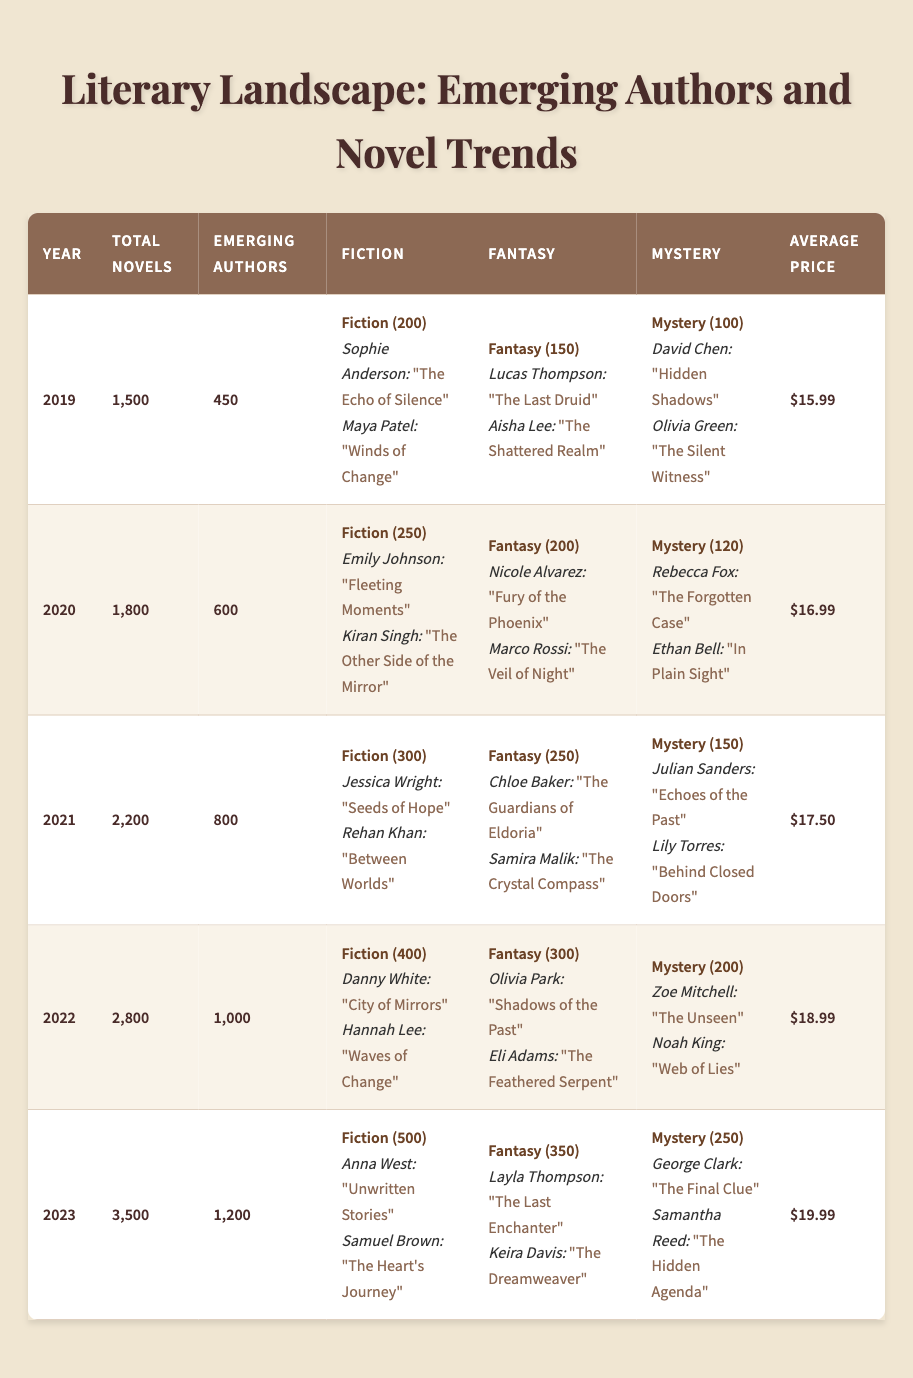What was the total number of novels published by emerging authors in 2022? The table lists that in 2022, there were 2,800 total novels published, and out of those, 1,000 were by emerging authors. Therefore, the answer is directly found in the table.
Answer: 1,000 Which genre had the highest number of novels published by emerging authors in 2021? In 2021, the fiction genre had 300 novels, fantasy had 250 novels, and mystery had 150 novels. Since 300 is the highest, the answer is fiction.
Answer: Fiction What was the increase in the number of emerging authors from 2019 to 2023? There were 450 emerging authors in 2019 and 1,200 in 2023. The increase is calculated by subtracting the two values: 1,200 - 450 = 750.
Answer: 750 Was the average price of novels higher in 2023 than in 2020? In 2023, the average price was $19.99, while in 2020 it was $16.99. Since $19.99 is greater than $16.99, this statement is true.
Answer: Yes How many total novels were published in the years 2019, 2020, and 2021 combined? The total novels for 2019 is 1,500, for 2020 is 1,800, and for 2021 is 2,200. Combining these values: 1,500 + 1,800 + 2,200 = 5,500 novels.
Answer: 5,500 Which year saw the most significant increase in the number of emerging authors? Comparing the data, from 2021 (800 authors) to 2022 (1,000 authors) is an increase of 200, and from 2022 (1,000 authors) to 2023 (1,200 authors) is an increase of 200. However, the increase from 2020 (600 authors) to 2021 (800 authors) is 200 as well. The increase between 2019 (450) and 2020 (600) is 150. Thus, each of the latter years had the highest increase of 200.
Answer: 2021-2022 and 2022-2023 What were the average prices of novels in the years with the highest publication rates? The years with the highest publication rates are 2022 (average price $18.99) and 2023 (average price $19.99). Thus, the average prices are compared, and $19.99 is the highest in 2023.
Answer: $19.99 In what year did fantasy novels by emerging authors reach 300 published works? In the table, fantasy novels reached 300 published works in 2022, as the previous years indicated lower numbers.
Answer: 2022 What percentage of the total novels published in 2023 were authored by emerging writers? In 2023, there were 3,500 total novels and 1,200 were authored by emerging authors. The percentage is calculated as (1,200 / 3,500) * 100, which equals approximately 34.29%.
Answer: 34.29% How many more novels in the mystery genre were published in 2023 compared to 2019? In 2023, 250 mystery novels were published, compared to 100 in 2019. Therefore, the difference is calculated as 250 - 100 = 150 more novels.
Answer: 150 Was there a consistent increase in total novels published each year from 2019 to 2023? By examining the total novels published in each year: 1,500 (2019), 1,800 (2020), 2,200 (2021), 2,800 (2022), and 3,500 (2023), it shows a consistent increase year after year.
Answer: Yes 